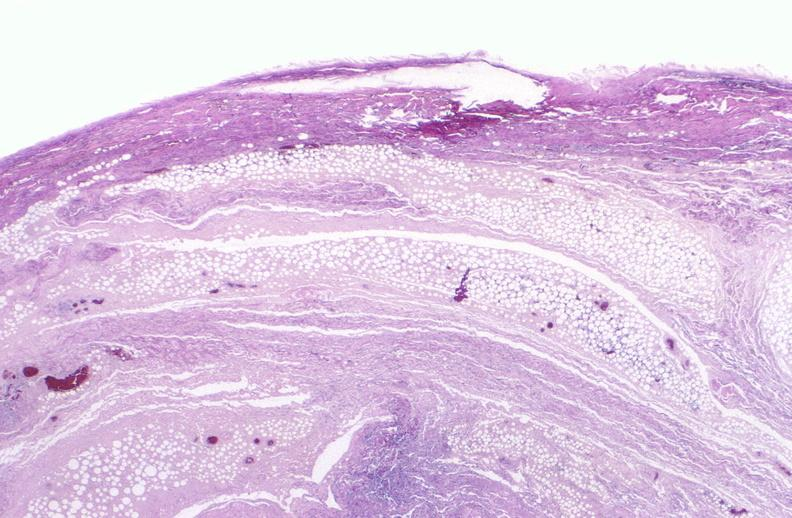does this image show panniculitis and fascitis?
Answer the question using a single word or phrase. Yes 